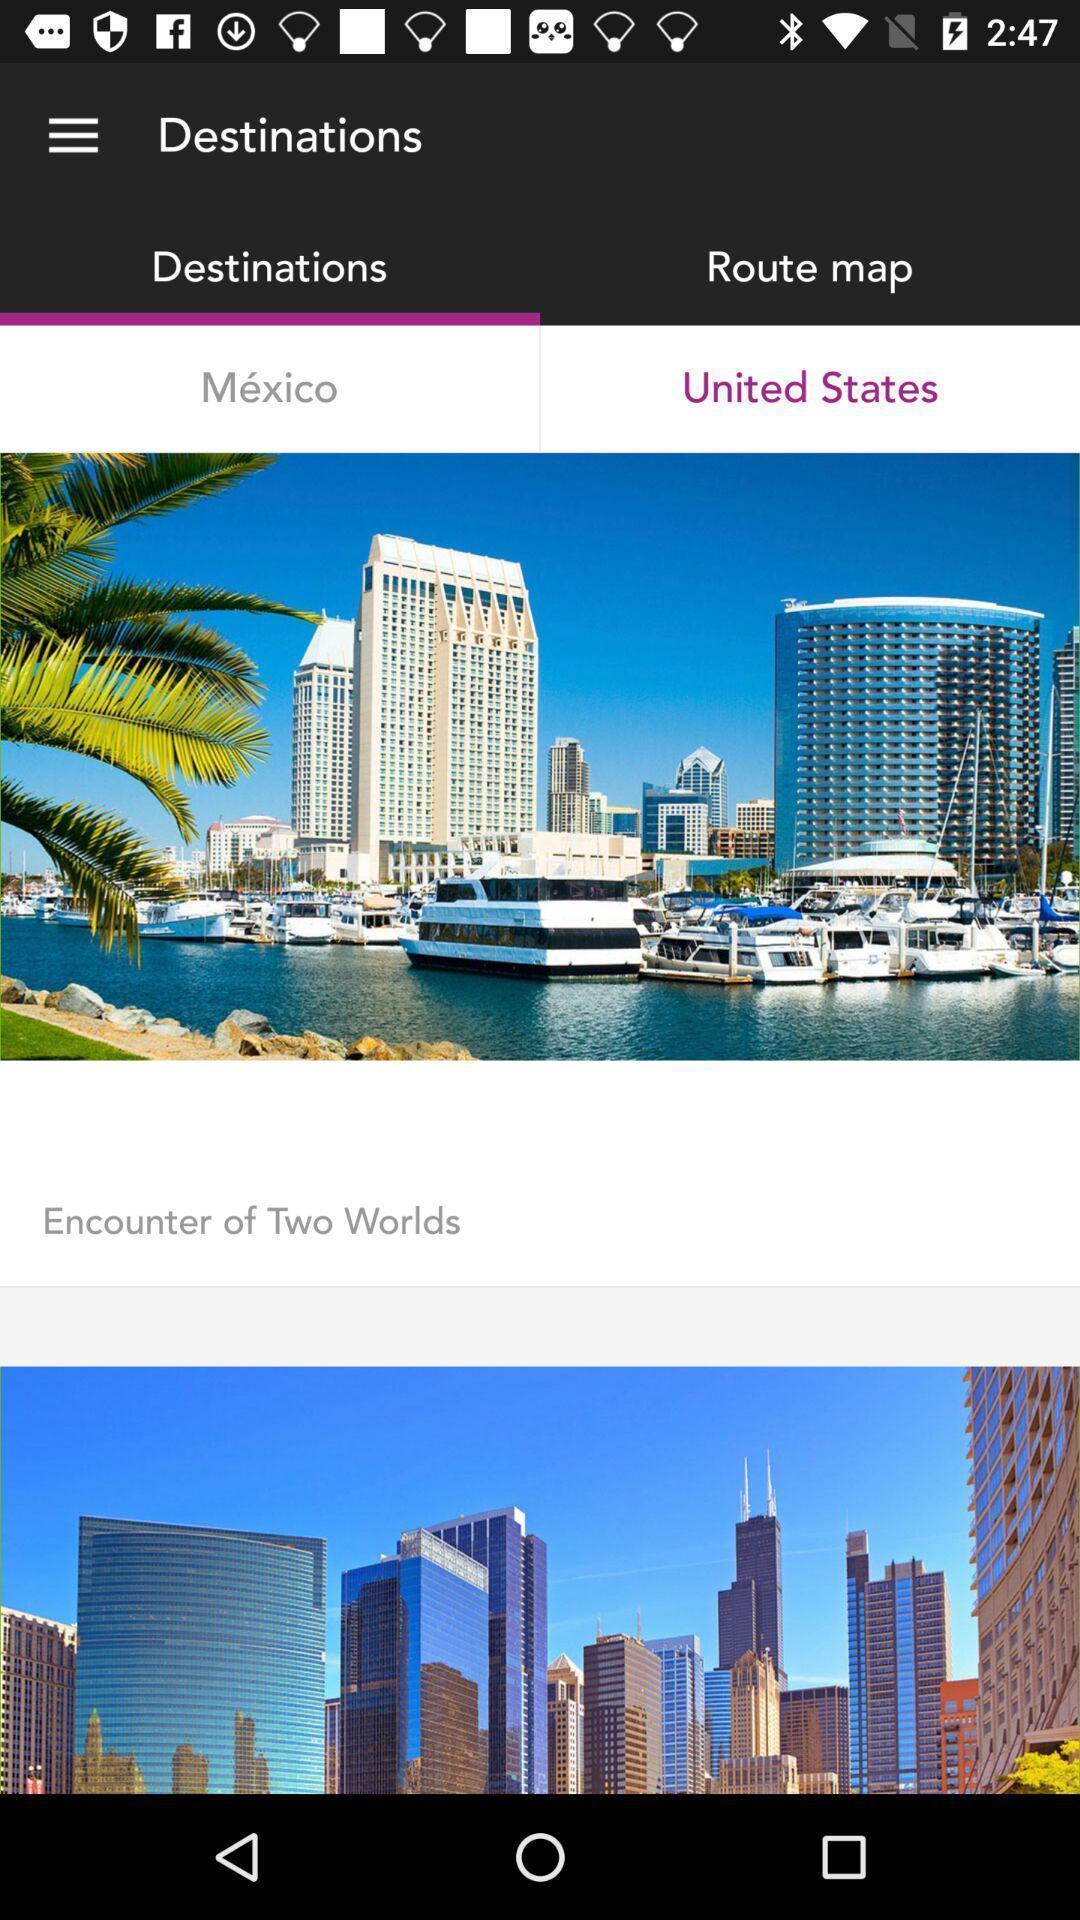Describe the key features of this screenshot. Screen page displaying different places. 